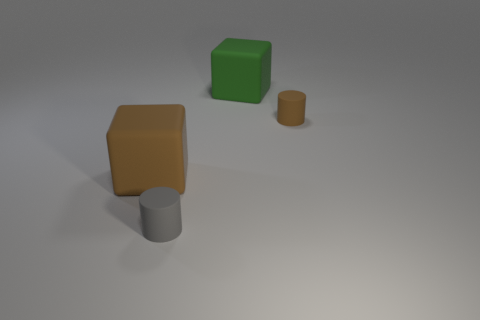Add 2 small purple metal blocks. How many objects exist? 6 Subtract 1 cubes. How many cubes are left? 1 Subtract all green blocks. Subtract all red balls. How many blocks are left? 1 Subtract all purple blocks. How many green cylinders are left? 0 Subtract all tiny gray objects. Subtract all small gray cylinders. How many objects are left? 2 Add 4 green things. How many green things are left? 5 Add 4 big yellow cubes. How many big yellow cubes exist? 4 Subtract 0 gray balls. How many objects are left? 4 